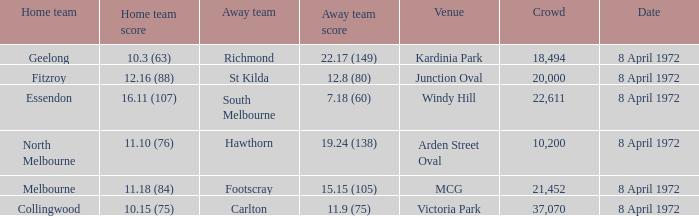Which location has a home team of geelong? Kardinia Park. 